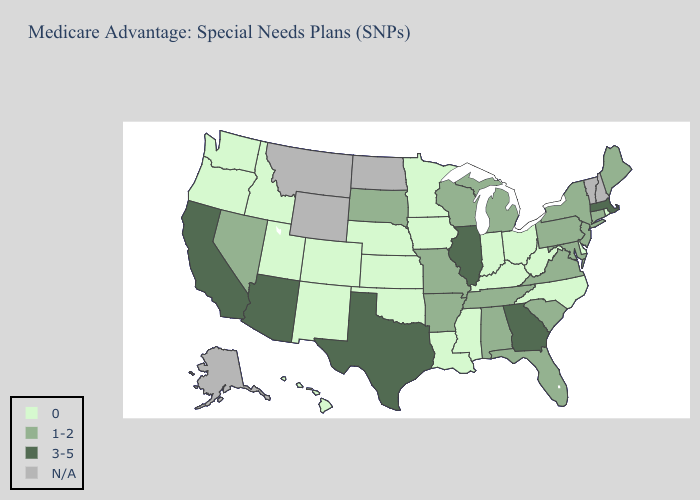What is the value of Iowa?
Keep it brief. 0. What is the highest value in the USA?
Quick response, please. 3-5. Which states hav the highest value in the Northeast?
Be succinct. Massachusetts. What is the value of Oregon?
Keep it brief. 0. Which states have the lowest value in the USA?
Concise answer only. Colorado, Delaware, Hawaii, Iowa, Idaho, Indiana, Kansas, Kentucky, Louisiana, Minnesota, Mississippi, North Carolina, Nebraska, New Mexico, Ohio, Oklahoma, Oregon, Rhode Island, Utah, Washington, West Virginia. Among the states that border Alabama , which have the highest value?
Quick response, please. Georgia. Name the states that have a value in the range 0?
Give a very brief answer. Colorado, Delaware, Hawaii, Iowa, Idaho, Indiana, Kansas, Kentucky, Louisiana, Minnesota, Mississippi, North Carolina, Nebraska, New Mexico, Ohio, Oklahoma, Oregon, Rhode Island, Utah, Washington, West Virginia. Among the states that border New Hampshire , does Massachusetts have the highest value?
Write a very short answer. Yes. Which states have the lowest value in the Northeast?
Keep it brief. Rhode Island. Which states have the lowest value in the USA?
Write a very short answer. Colorado, Delaware, Hawaii, Iowa, Idaho, Indiana, Kansas, Kentucky, Louisiana, Minnesota, Mississippi, North Carolina, Nebraska, New Mexico, Ohio, Oklahoma, Oregon, Rhode Island, Utah, Washington, West Virginia. What is the value of Maine?
Quick response, please. 1-2. Does Virginia have the lowest value in the USA?
Be succinct. No. Name the states that have a value in the range N/A?
Concise answer only. Alaska, Montana, North Dakota, New Hampshire, Vermont, Wyoming. What is the value of Kansas?
Be succinct. 0. 